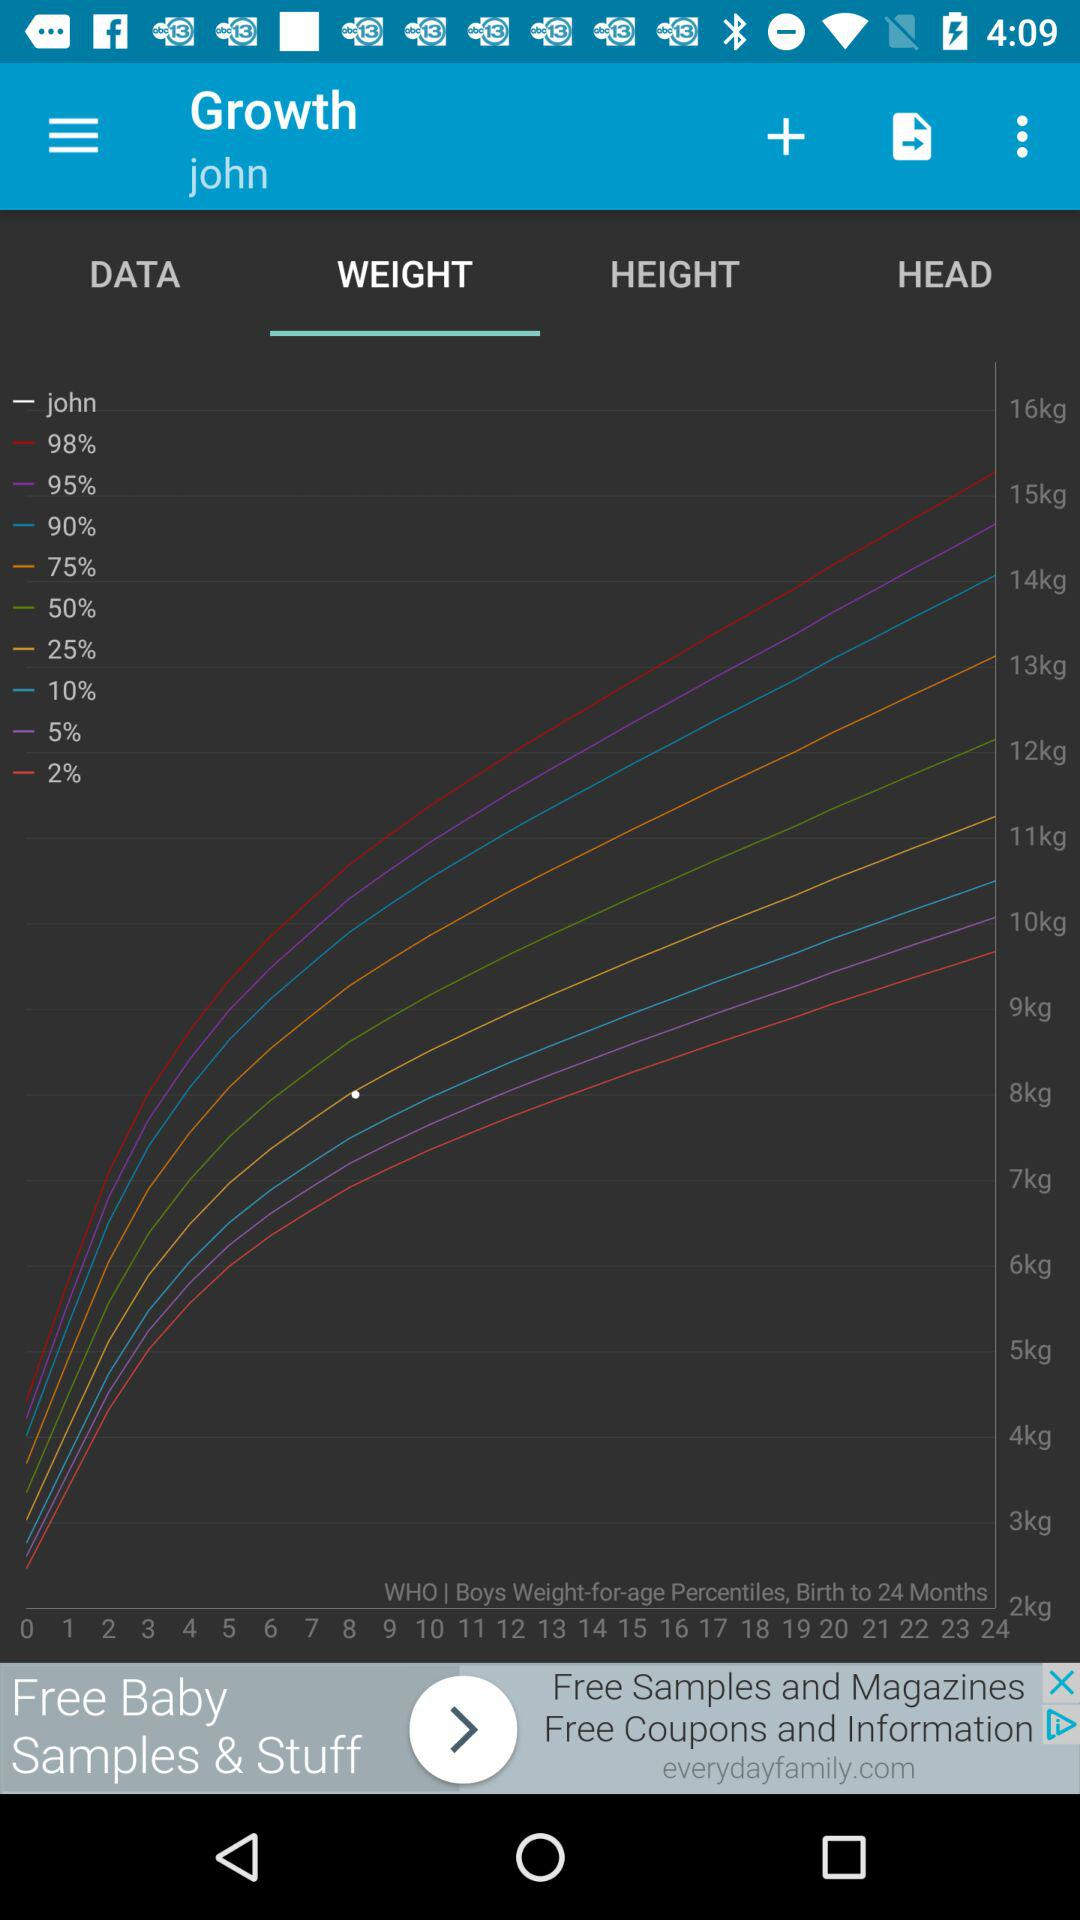Which chart is being shown right now? The chart that is being shown right now is "WEIGHT". 